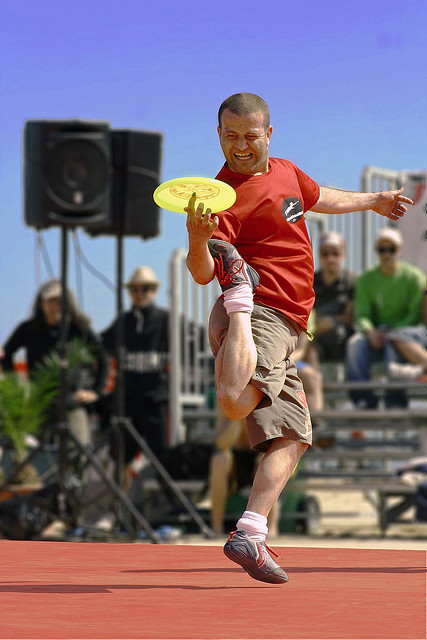<image>What letter repeats on the man's shirt? I am not sure what letter repeats on the man's shirt. It appears there may be no letters. What letter repeats on the man's shirt? I don't know which letter repeats on the man's shirt. It seems that there are no letters on his shirt. 